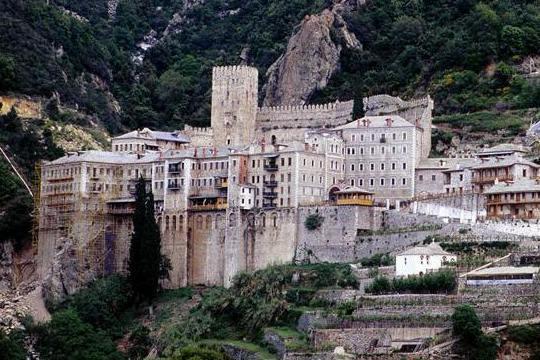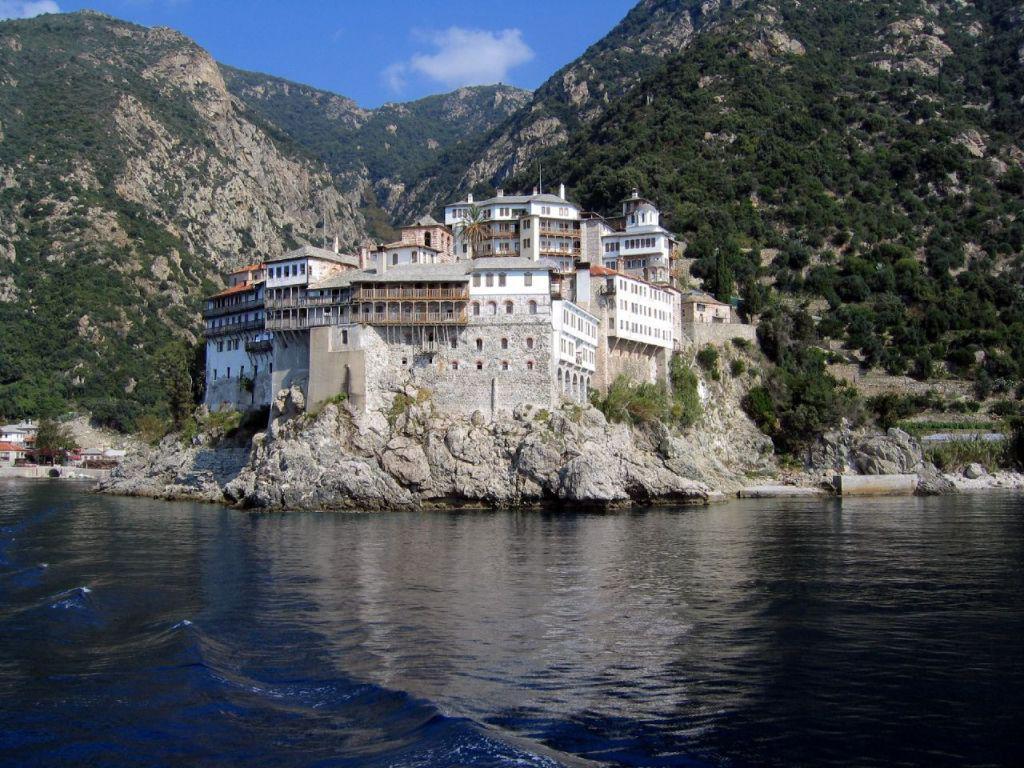The first image is the image on the left, the second image is the image on the right. Considering the images on both sides, is "Only one of the images show a body of water." valid? Answer yes or no. Yes. The first image is the image on the left, the second image is the image on the right. Assess this claim about the two images: "there is water in the image on the right". Correct or not? Answer yes or no. Yes. 